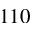<formula> <loc_0><loc_0><loc_500><loc_500>1 1 0</formula> 